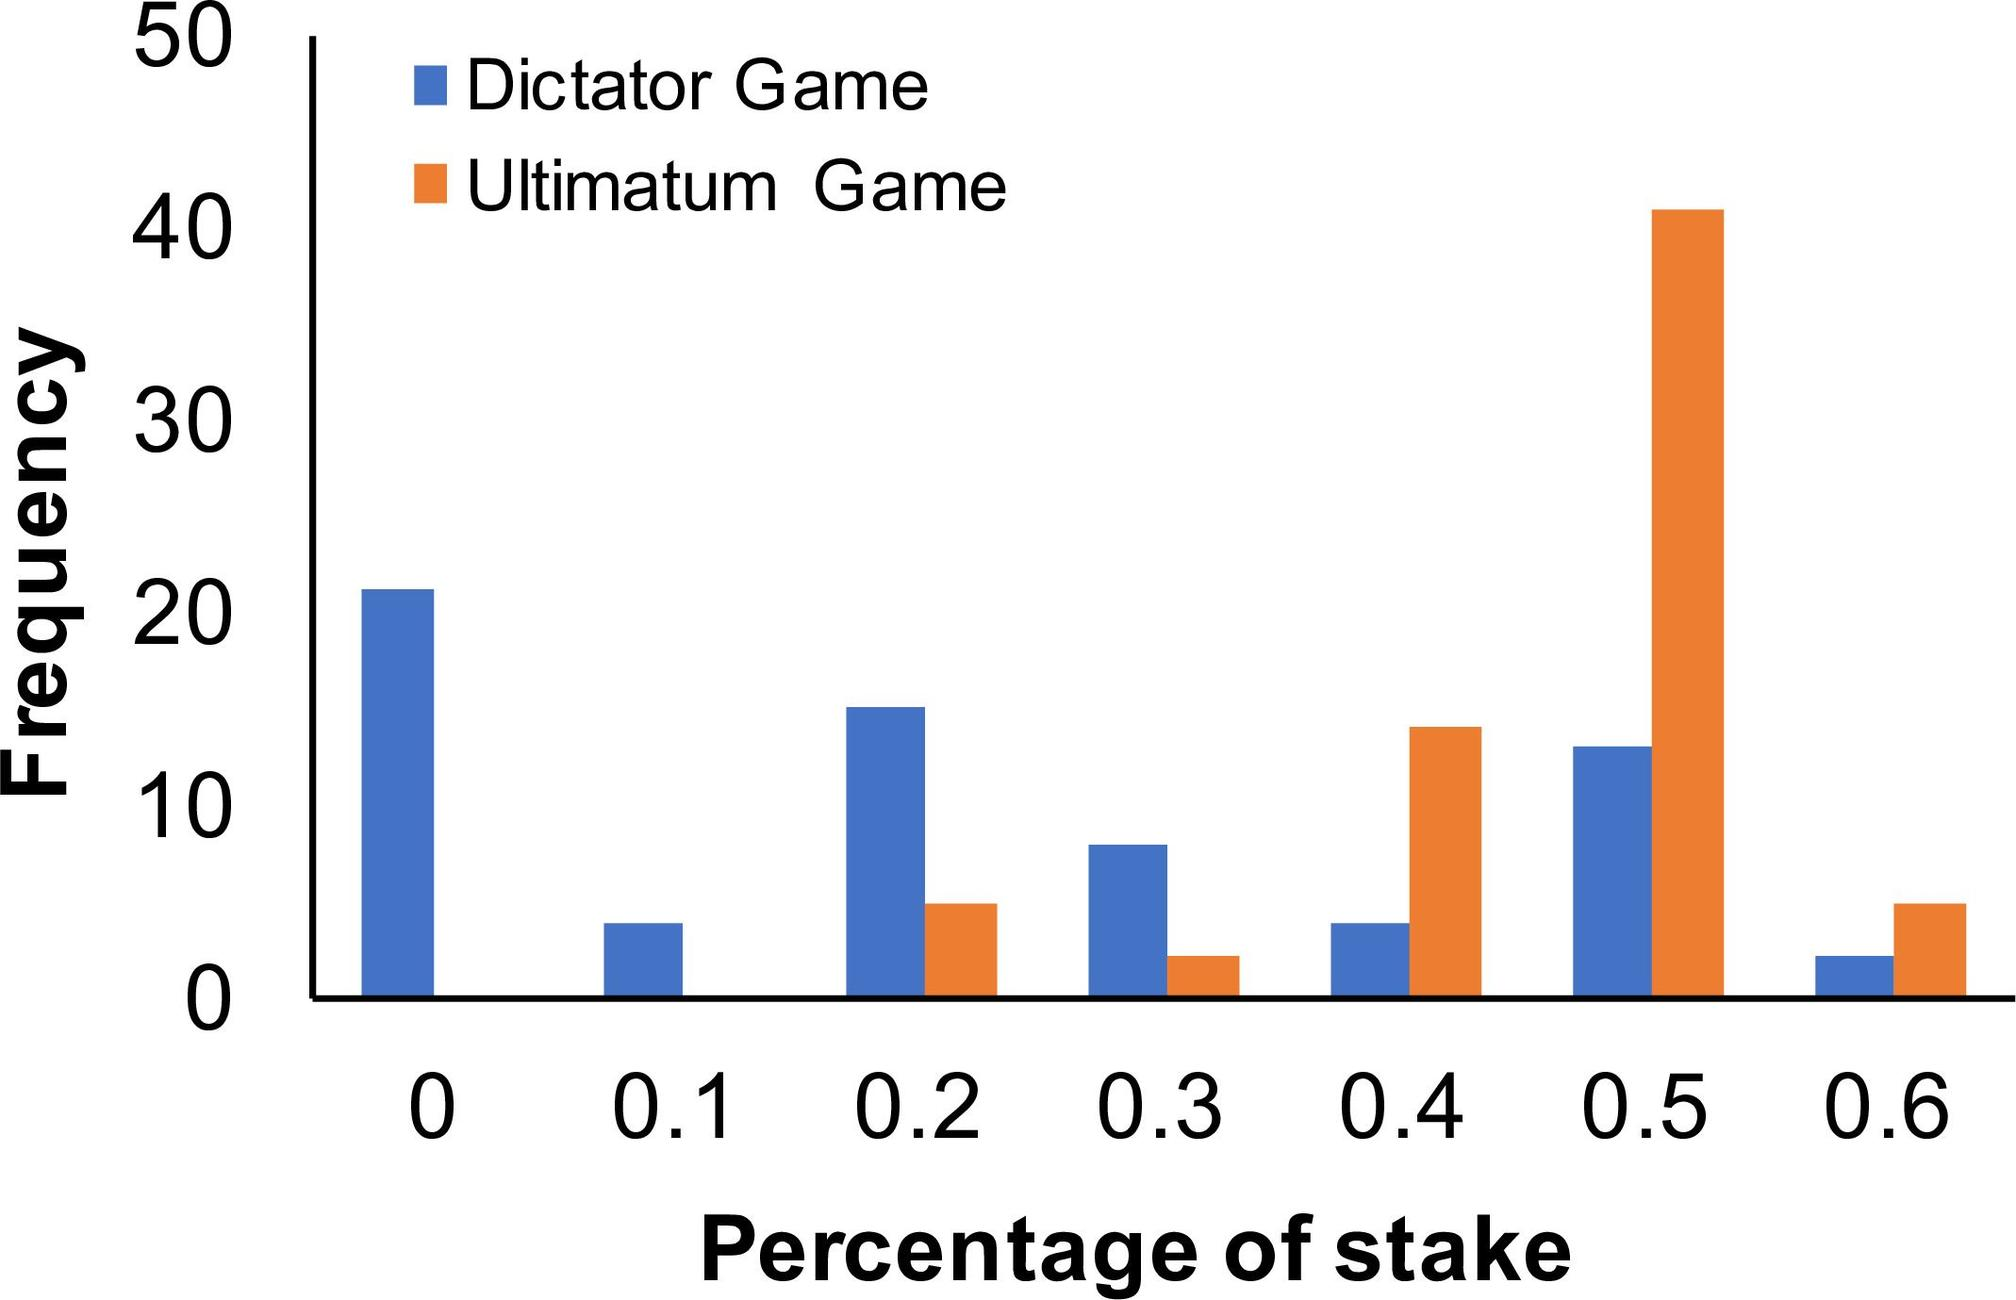Based on the data, which game demonstrates a higher frequency of offers at the 0.5 stake level? A. Dictator Game B. Ultimatum Game C. Both games show the same frequency D. The data does not specify frequencies at the 0.5 stake level The bar graph illustrated clearly shows that, at a stake level of 0.5, the Ultimatum Game experiences significantly more offers than the Dictator Game, with its frequency bar markedly higher. Specifically, the Ultimatum Game's bar reaches near 40 while the Dictator Game's bar is below 10. Thus, the correct answer is B. Ultimatum Game. 